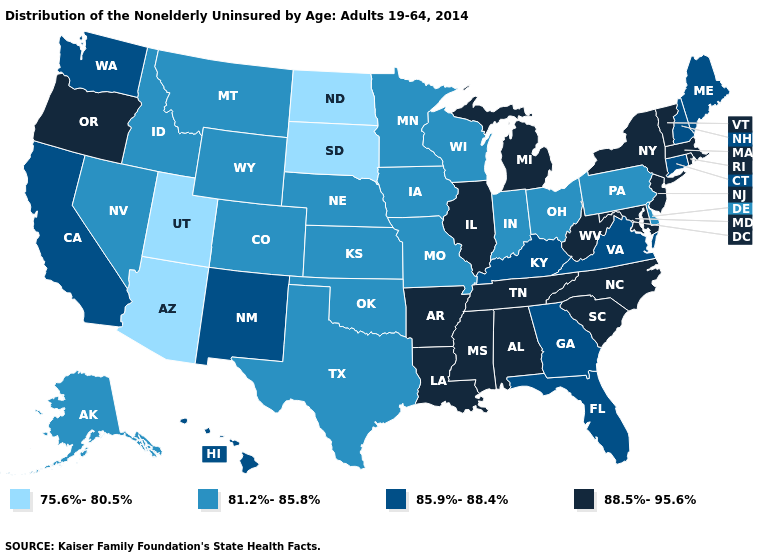Does the map have missing data?
Keep it brief. No. Does New Jersey have the highest value in the Northeast?
Give a very brief answer. Yes. Among the states that border Minnesota , which have the highest value?
Answer briefly. Iowa, Wisconsin. What is the value of Rhode Island?
Answer briefly. 88.5%-95.6%. Name the states that have a value in the range 88.5%-95.6%?
Answer briefly. Alabama, Arkansas, Illinois, Louisiana, Maryland, Massachusetts, Michigan, Mississippi, New Jersey, New York, North Carolina, Oregon, Rhode Island, South Carolina, Tennessee, Vermont, West Virginia. What is the lowest value in the MidWest?
Answer briefly. 75.6%-80.5%. What is the value of North Dakota?
Answer briefly. 75.6%-80.5%. What is the value of Utah?
Keep it brief. 75.6%-80.5%. What is the value of Michigan?
Answer briefly. 88.5%-95.6%. Is the legend a continuous bar?
Keep it brief. No. How many symbols are there in the legend?
Be succinct. 4. Does Missouri have the same value as Wisconsin?
Concise answer only. Yes. Does the first symbol in the legend represent the smallest category?
Quick response, please. Yes. Name the states that have a value in the range 85.9%-88.4%?
Quick response, please. California, Connecticut, Florida, Georgia, Hawaii, Kentucky, Maine, New Hampshire, New Mexico, Virginia, Washington. Does Vermont have the lowest value in the Northeast?
Concise answer only. No. 